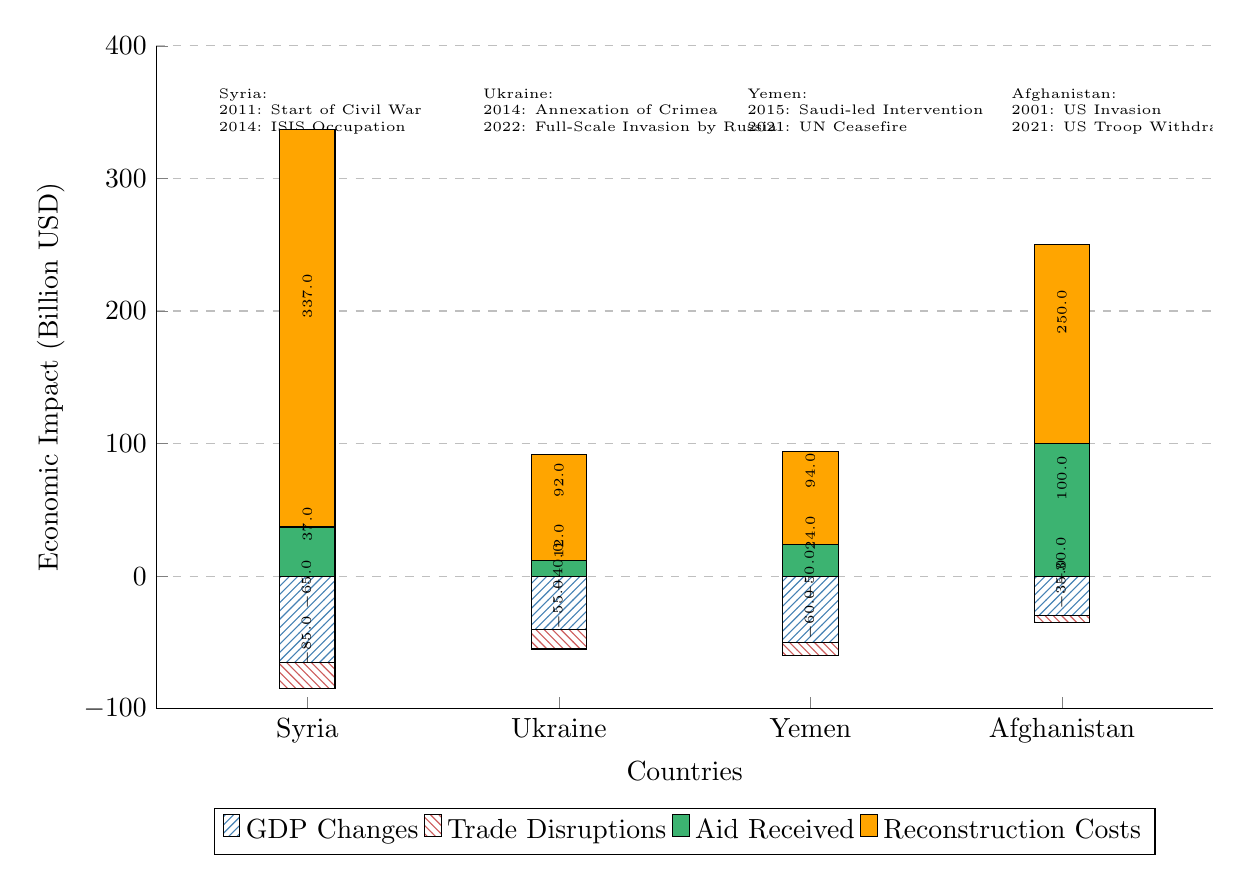What is the GDP change for Syria? In the diagram, the GDP change for Syria is represented by the bar that shows a value of -65 billion USD. This can be easily identified by looking at the blue section of the bar for Syria.
Answer: -65 billion USD What is the reconstruction cost for Yemen? The reconstruction cost for Yemen is indicated by the orange section of the bar for Yemen, which shows a value of 70 billion USD. This is determined by reading the y-axis value corresponding to the orange bar for that country.
Answer: 70 billion USD Which country received the highest amount of aid? By comparing the green sections of the bars, we can see that Afghanistan has the highest aid received at 100 billion USD, as indicated by the length of its green bar being the tallest among the others.
Answer: Afghanistan How do the trade disruptions in Syria compare to those in Afghanistan? The trade disruptions can be analyzed by examining the red sections of the bars for Syria and Afghanistan. The red section for Syria shows a value of -20 billion USD, while for Afghanistan, it shows -5 billion USD. Thus, trade disruptions in Syria are greater than those in Afghanistan by 15 billion USD.
Answer: Greater by 15 billion USD What is the combined economic impact for Ukraine? The combined economic impact for Ukraine can be calculated by summing the values of its four economic indicators: GDP change (-40 billion), trade disruptions (-15 billion), aid received (12 billion), and reconstruction costs (80 billion). This results in a total of 37 billion USD when negative values are subtracted from the positive ones.
Answer: 37 billion USD Which country experienced a full-scale invasion that affected its GDP? The diagram annotations indicate that Ukraine experienced a full-scale invasion by Russia in 2022, which significantly impacted its GDP.
Answer: Ukraine What was the GDP change for Afghanistan? The GDP change for Afghanistan is reflected in the blue section of its bar, which shows a value of -30 billion USD. This can be verified by locating the corresponding blue bar for Afghanistan on the diagram.
Answer: -30 billion USD How much aid did Syria receive compared to Yemen? Looking at the green sections, Syria received 37 billion USD in aid, while Yemen received 24 billion USD in aid. Therefore, Syria received 13 billion USD more in aid compared to Yemen.
Answer: 13 billion USD more 